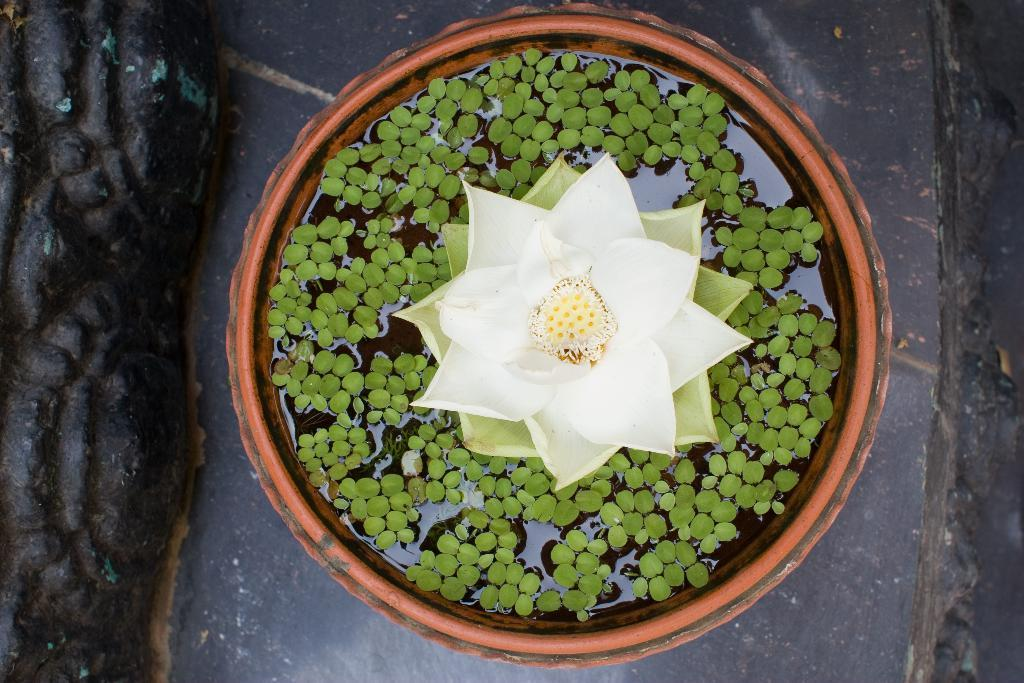What is the main object in the image? There is a pot in the image. What is on the pot? There is a flower on the pot. What additional details can be observed about the flower? There are leaves on the flower. What type of skate is being used to water the flower in the image? There is no skate present in the image, and the flower is not being watered. 